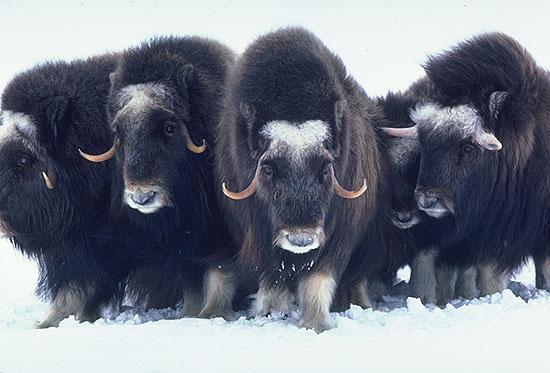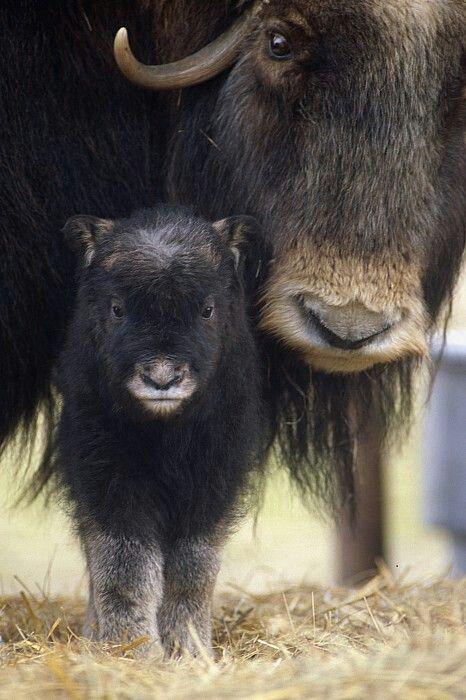The first image is the image on the left, the second image is the image on the right. Given the left and right images, does the statement "An image shows a man wielding a stick behind a plow pulled by two cattle." hold true? Answer yes or no. No. The first image is the image on the left, the second image is the image on the right. Examine the images to the left and right. Is the description "In one image, a farmer is guiding a plow that two animals with horns are pulling through a watery field." accurate? Answer yes or no. No. 